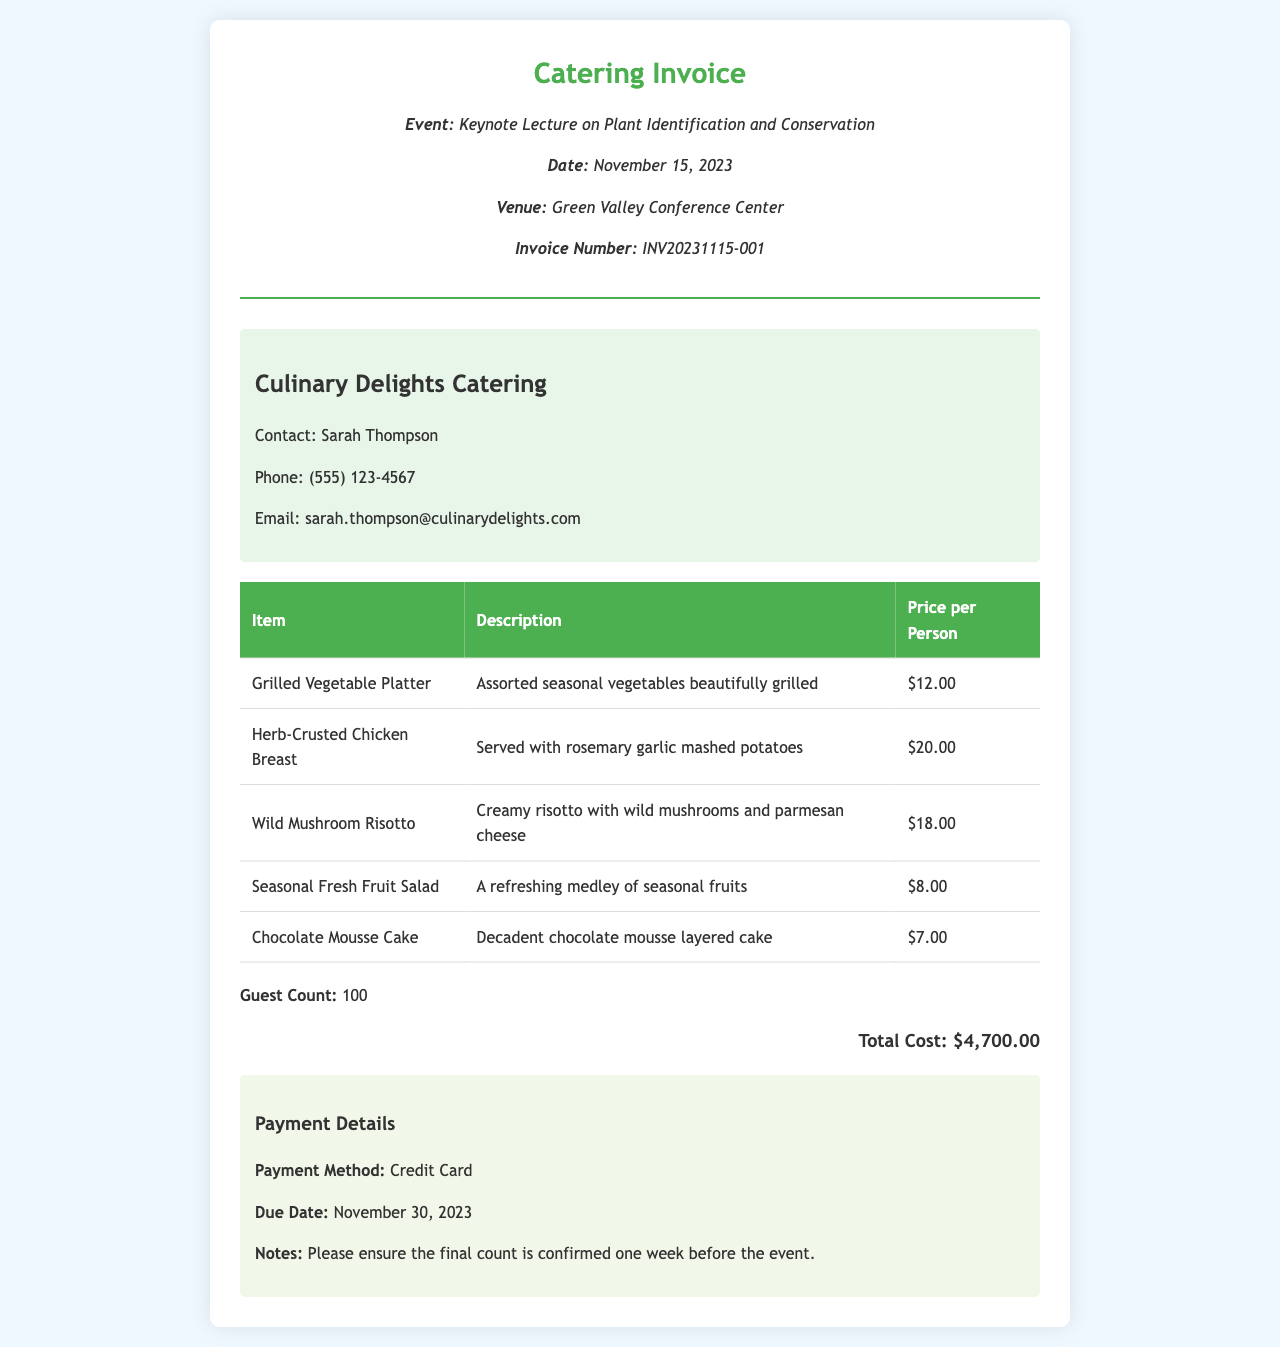What is the event name? The event name is mentioned as "Keynote Lecture on Plant Identification and Conservation."
Answer: Keynote Lecture on Plant Identification and Conservation What is the invoice number? The invoice number is indicated as "INV20231115-001."
Answer: INV20231115-001 How many guests are counted? The document specifies a guest count of "100."
Answer: 100 What is the price per person for the Herb-Crusted Chicken Breast? The price for the Herb-Crusted Chicken Breast is listed as "$20.00."
Answer: $20.00 What is the total cost of the catering services? The total cost is shown as "$4,700.00."
Answer: $4,700.00 Who is the contact person for the catering? The contact person is named "Sarah Thompson."
Answer: Sarah Thompson What payment method is accepted? The payment method specified is "Credit Card."
Answer: Credit Card What is the due date for payment? The due date for payment is mentioned as "November 30, 2023."
Answer: November 30, 2023 What type of salad is included in the menu? The menu includes a "Seasonal Fresh Fruit Salad."
Answer: Seasonal Fresh Fruit Salad 